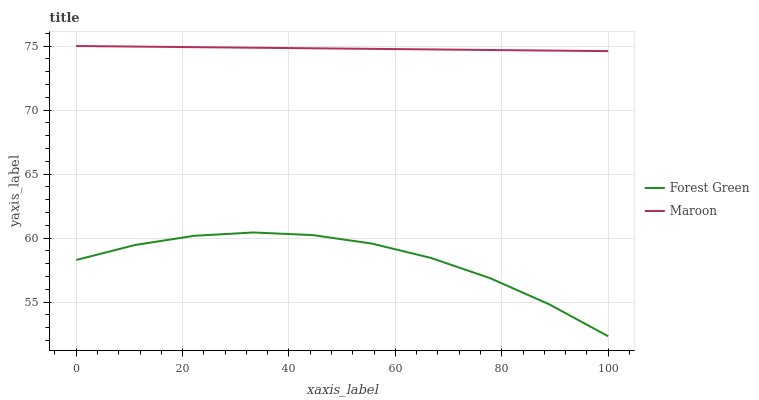Does Forest Green have the minimum area under the curve?
Answer yes or no. Yes. Does Maroon have the maximum area under the curve?
Answer yes or no. Yes. Does Maroon have the minimum area under the curve?
Answer yes or no. No. Is Maroon the smoothest?
Answer yes or no. Yes. Is Forest Green the roughest?
Answer yes or no. Yes. Is Maroon the roughest?
Answer yes or no. No. Does Forest Green have the lowest value?
Answer yes or no. Yes. Does Maroon have the lowest value?
Answer yes or no. No. Does Maroon have the highest value?
Answer yes or no. Yes. Is Forest Green less than Maroon?
Answer yes or no. Yes. Is Maroon greater than Forest Green?
Answer yes or no. Yes. Does Forest Green intersect Maroon?
Answer yes or no. No. 